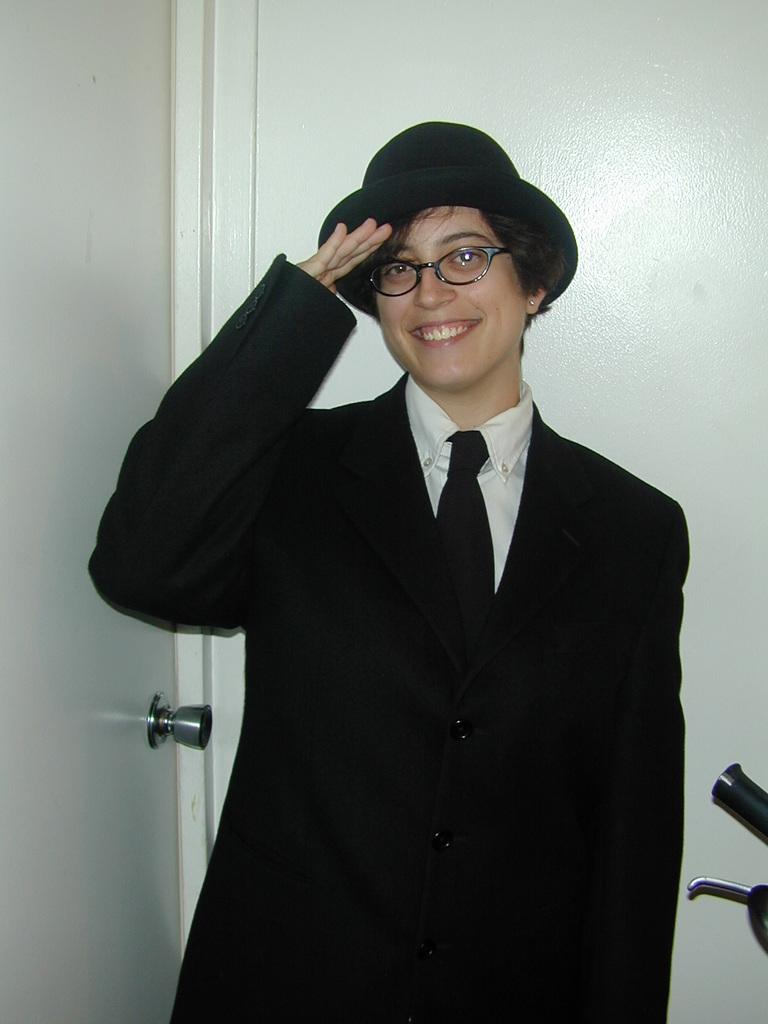Who is present in the image? There is a woman in the image. What is the woman doing in the image? The woman is standing. What is the woman wearing on her head? The woman is wearing a cap on her head. What can be seen on the left side of the image? There is a door on the left side of the image. What is visible in the background of the image? There is a wall in the background of the image. Can you see any eggs being cracked by the woman's thumb in the image? There is no thumb or eggs present in the image. What type of seashore can be seen in the background of the image? There is no seashore present in the image; it features a wall in the background. 